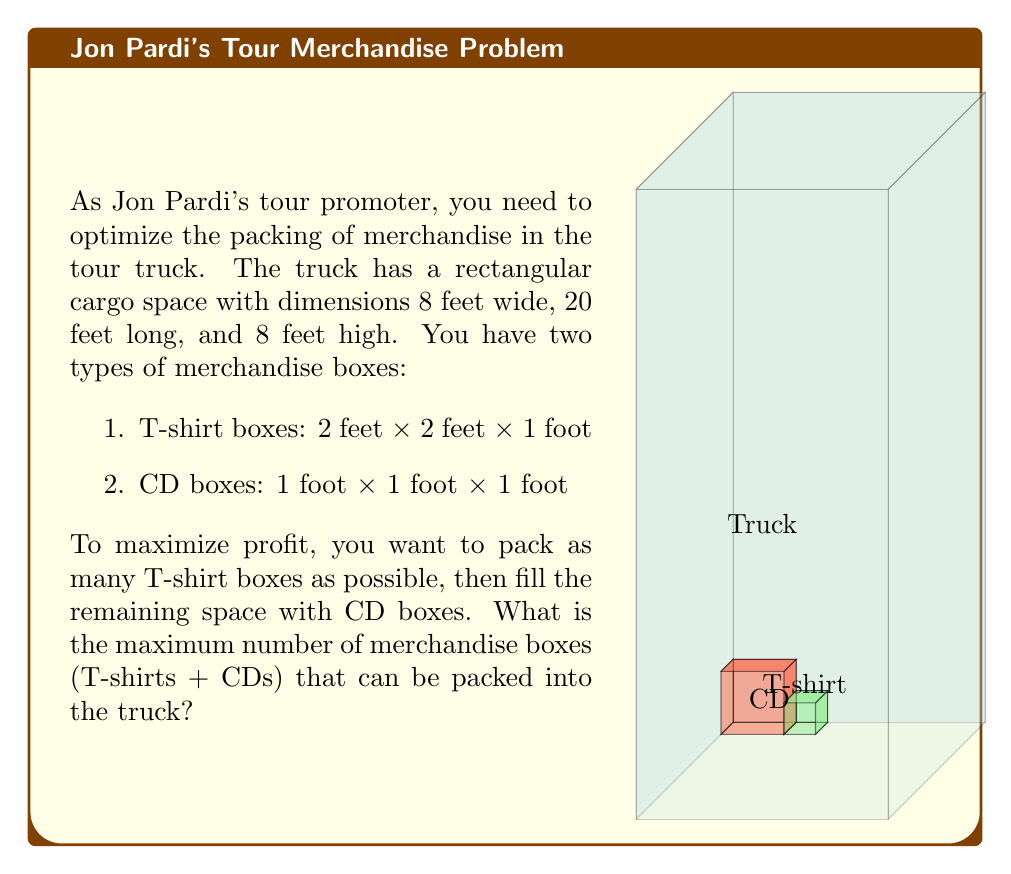What is the answer to this math problem? Let's approach this problem step-by-step:

1) First, calculate the total volume of the truck:
   $V_{truck} = 8 \times 20 \times 8 = 1280$ cubic feet

2) Calculate the volume of each type of box:
   $V_{T-shirt} = 2 \times 2 \times 1 = 4$ cubic feet
   $V_{CD} = 1 \times 1 \times 1 = 1$ cubic foot

3) Determine how many T-shirt boxes can fit in each dimension:
   Width: $\lfloor 8 \div 2 \rfloor = 4$ boxes
   Length: $\lfloor 20 \div 2 \rfloor = 10$ boxes
   Height: $\lfloor 8 \div 1 \rfloor = 8$ boxes

4) Calculate the total number of T-shirt boxes:
   $N_{T-shirt} = 4 \times 10 \times 8 = 320$ boxes

5) Calculate the volume occupied by T-shirt boxes:
   $V_{occupied} = 320 \times 4 = 1280$ cubic feet

6) Calculate the remaining volume for CD boxes:
   $V_{remaining} = V_{truck} - V_{occupied} = 1280 - 1280 = 0$ cubic feet

7) Since there's no remaining space, we can't fit any CD boxes.

8) The total number of merchandise boxes is:
   $N_{total} = N_{T-shirt} + N_{CD} = 320 + 0 = 320$ boxes
Answer: 320 boxes 